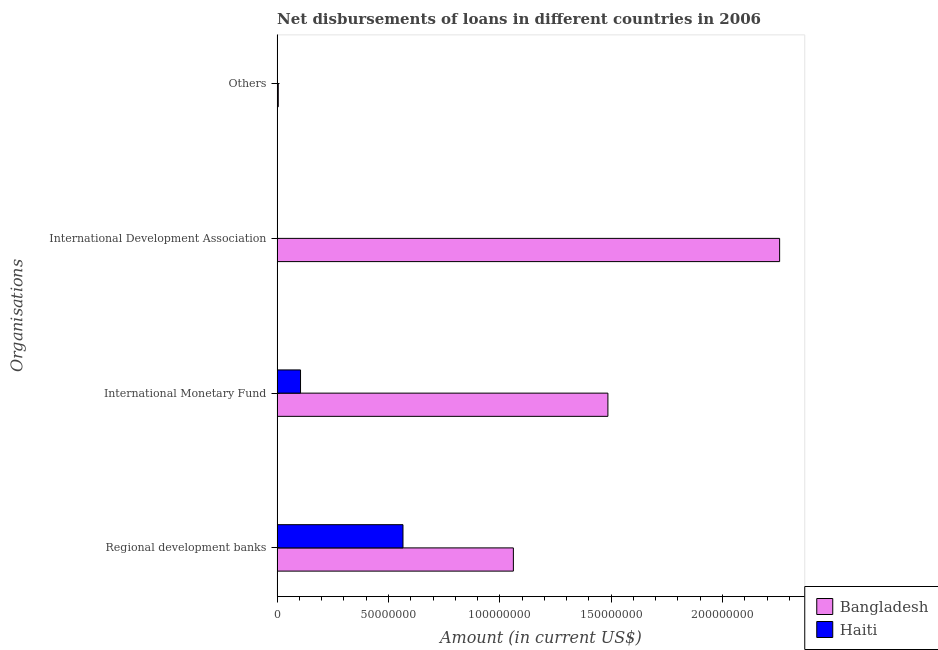How many different coloured bars are there?
Ensure brevity in your answer.  2. Are the number of bars on each tick of the Y-axis equal?
Offer a very short reply. No. How many bars are there on the 3rd tick from the top?
Provide a short and direct response. 2. How many bars are there on the 3rd tick from the bottom?
Ensure brevity in your answer.  1. What is the label of the 3rd group of bars from the top?
Your response must be concise. International Monetary Fund. What is the amount of loan disimbursed by other organisations in Bangladesh?
Your answer should be very brief. 5.21e+05. Across all countries, what is the maximum amount of loan disimbursed by other organisations?
Ensure brevity in your answer.  5.21e+05. Across all countries, what is the minimum amount of loan disimbursed by other organisations?
Provide a short and direct response. 0. In which country was the amount of loan disimbursed by regional development banks maximum?
Ensure brevity in your answer.  Bangladesh. What is the total amount of loan disimbursed by international monetary fund in the graph?
Make the answer very short. 1.59e+08. What is the difference between the amount of loan disimbursed by regional development banks in Haiti and that in Bangladesh?
Provide a short and direct response. -4.96e+07. What is the difference between the amount of loan disimbursed by international development association in Bangladesh and the amount of loan disimbursed by other organisations in Haiti?
Give a very brief answer. 2.26e+08. What is the average amount of loan disimbursed by regional development banks per country?
Offer a terse response. 8.13e+07. What is the difference between the amount of loan disimbursed by international monetary fund and amount of loan disimbursed by other organisations in Bangladesh?
Your answer should be compact. 1.48e+08. In how many countries, is the amount of loan disimbursed by other organisations greater than 30000000 US$?
Offer a terse response. 0. What is the ratio of the amount of loan disimbursed by regional development banks in Haiti to that in Bangladesh?
Provide a short and direct response. 0.53. What is the difference between the highest and the second highest amount of loan disimbursed by international monetary fund?
Your answer should be very brief. 1.38e+08. What is the difference between the highest and the lowest amount of loan disimbursed by international development association?
Keep it short and to the point. 2.26e+08. In how many countries, is the amount of loan disimbursed by international development association greater than the average amount of loan disimbursed by international development association taken over all countries?
Provide a succinct answer. 1. Is the sum of the amount of loan disimbursed by international monetary fund in Haiti and Bangladesh greater than the maximum amount of loan disimbursed by regional development banks across all countries?
Give a very brief answer. Yes. Is it the case that in every country, the sum of the amount of loan disimbursed by regional development banks and amount of loan disimbursed by international monetary fund is greater than the amount of loan disimbursed by international development association?
Ensure brevity in your answer.  Yes. How many bars are there?
Your response must be concise. 6. What is the difference between two consecutive major ticks on the X-axis?
Ensure brevity in your answer.  5.00e+07. Does the graph contain grids?
Ensure brevity in your answer.  No. What is the title of the graph?
Make the answer very short. Net disbursements of loans in different countries in 2006. Does "Slovenia" appear as one of the legend labels in the graph?
Your response must be concise. No. What is the label or title of the X-axis?
Ensure brevity in your answer.  Amount (in current US$). What is the label or title of the Y-axis?
Offer a very short reply. Organisations. What is the Amount (in current US$) of Bangladesh in Regional development banks?
Make the answer very short. 1.06e+08. What is the Amount (in current US$) of Haiti in Regional development banks?
Offer a terse response. 5.65e+07. What is the Amount (in current US$) in Bangladesh in International Monetary Fund?
Provide a succinct answer. 1.49e+08. What is the Amount (in current US$) of Haiti in International Monetary Fund?
Your answer should be compact. 1.05e+07. What is the Amount (in current US$) in Bangladesh in International Development Association?
Ensure brevity in your answer.  2.26e+08. What is the Amount (in current US$) in Haiti in International Development Association?
Provide a succinct answer. 0. What is the Amount (in current US$) in Bangladesh in Others?
Ensure brevity in your answer.  5.21e+05. Across all Organisations, what is the maximum Amount (in current US$) of Bangladesh?
Your response must be concise. 2.26e+08. Across all Organisations, what is the maximum Amount (in current US$) in Haiti?
Offer a terse response. 5.65e+07. Across all Organisations, what is the minimum Amount (in current US$) in Bangladesh?
Offer a very short reply. 5.21e+05. What is the total Amount (in current US$) in Bangladesh in the graph?
Your answer should be very brief. 4.81e+08. What is the total Amount (in current US$) in Haiti in the graph?
Your answer should be compact. 6.70e+07. What is the difference between the Amount (in current US$) in Bangladesh in Regional development banks and that in International Monetary Fund?
Offer a very short reply. -4.24e+07. What is the difference between the Amount (in current US$) of Haiti in Regional development banks and that in International Monetary Fund?
Give a very brief answer. 4.60e+07. What is the difference between the Amount (in current US$) in Bangladesh in Regional development banks and that in International Development Association?
Your answer should be compact. -1.20e+08. What is the difference between the Amount (in current US$) of Bangladesh in Regional development banks and that in Others?
Keep it short and to the point. 1.06e+08. What is the difference between the Amount (in current US$) of Bangladesh in International Monetary Fund and that in International Development Association?
Your response must be concise. -7.71e+07. What is the difference between the Amount (in current US$) in Bangladesh in International Monetary Fund and that in Others?
Your response must be concise. 1.48e+08. What is the difference between the Amount (in current US$) in Bangladesh in International Development Association and that in Others?
Ensure brevity in your answer.  2.25e+08. What is the difference between the Amount (in current US$) of Bangladesh in Regional development banks and the Amount (in current US$) of Haiti in International Monetary Fund?
Your response must be concise. 9.56e+07. What is the average Amount (in current US$) of Bangladesh per Organisations?
Ensure brevity in your answer.  1.20e+08. What is the average Amount (in current US$) in Haiti per Organisations?
Make the answer very short. 1.68e+07. What is the difference between the Amount (in current US$) of Bangladesh and Amount (in current US$) of Haiti in Regional development banks?
Your answer should be compact. 4.96e+07. What is the difference between the Amount (in current US$) in Bangladesh and Amount (in current US$) in Haiti in International Monetary Fund?
Ensure brevity in your answer.  1.38e+08. What is the ratio of the Amount (in current US$) in Bangladesh in Regional development banks to that in International Monetary Fund?
Your answer should be very brief. 0.71. What is the ratio of the Amount (in current US$) of Haiti in Regional development banks to that in International Monetary Fund?
Offer a terse response. 5.38. What is the ratio of the Amount (in current US$) of Bangladesh in Regional development banks to that in International Development Association?
Make the answer very short. 0.47. What is the ratio of the Amount (in current US$) of Bangladesh in Regional development banks to that in Others?
Keep it short and to the point. 203.63. What is the ratio of the Amount (in current US$) in Bangladesh in International Monetary Fund to that in International Development Association?
Give a very brief answer. 0.66. What is the ratio of the Amount (in current US$) of Bangladesh in International Monetary Fund to that in Others?
Offer a very short reply. 285.1. What is the ratio of the Amount (in current US$) of Bangladesh in International Development Association to that in Others?
Your answer should be compact. 433.11. What is the difference between the highest and the second highest Amount (in current US$) in Bangladesh?
Your response must be concise. 7.71e+07. What is the difference between the highest and the lowest Amount (in current US$) of Bangladesh?
Your answer should be very brief. 2.25e+08. What is the difference between the highest and the lowest Amount (in current US$) in Haiti?
Ensure brevity in your answer.  5.65e+07. 